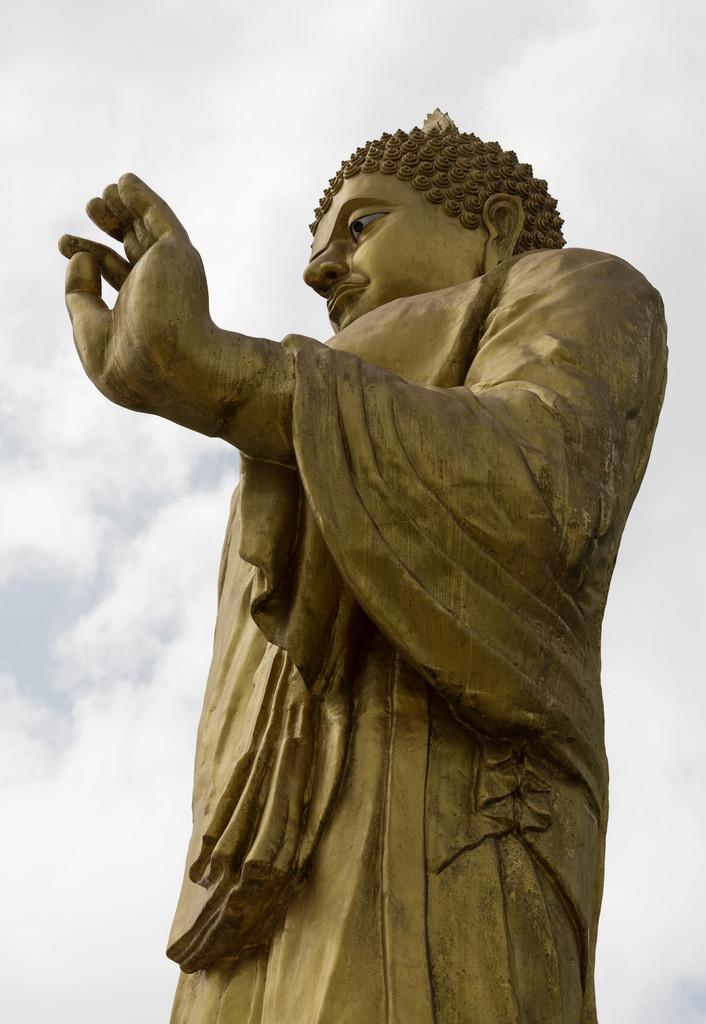What is the main subject of the picture? The main subject of the picture is a statue of Buddha. What can be seen in the background of the picture? The sky is visible in the background of the picture. How many buttons can be seen on the statue of Buddha in the image? There are no buttons present on the statue of Buddha in the image. What type of elbow is visible on the statue of Buddha in the image? There is no elbow present on the statue of Buddha in the image, as it is a statue and not a living being. 